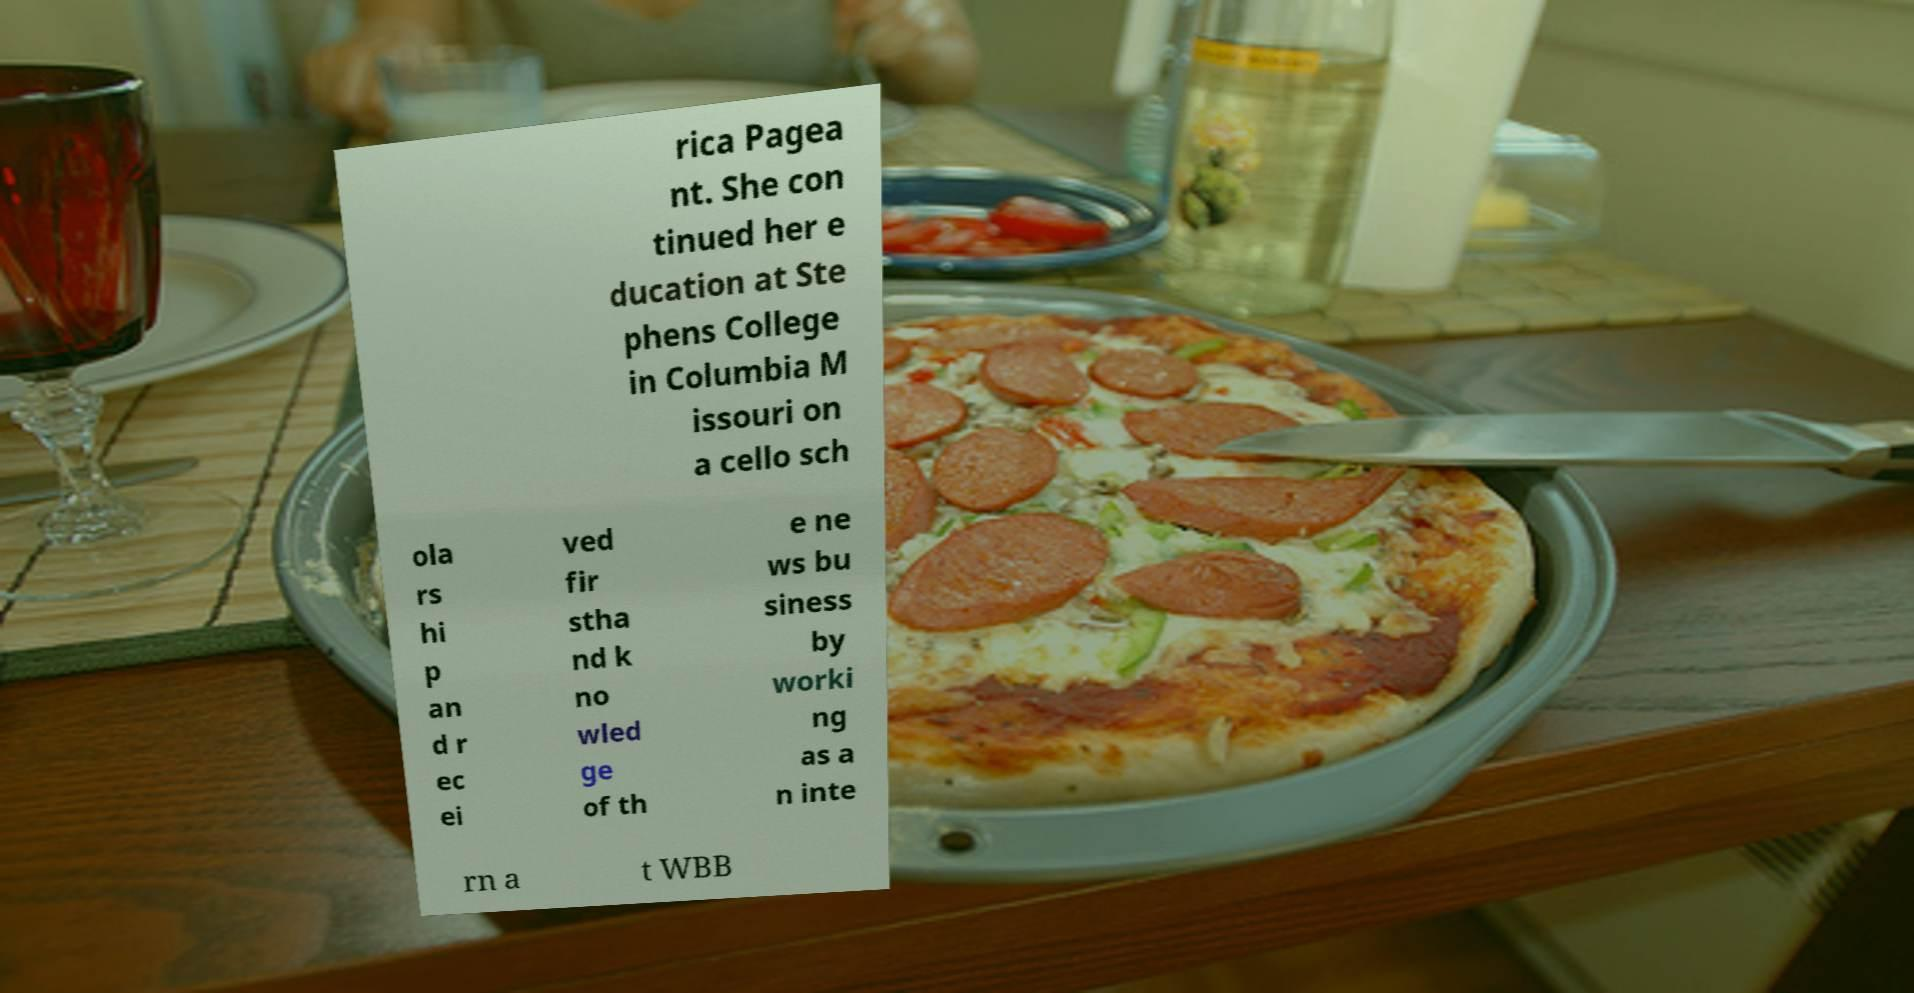Please identify and transcribe the text found in this image. rica Pagea nt. She con tinued her e ducation at Ste phens College in Columbia M issouri on a cello sch ola rs hi p an d r ec ei ved fir stha nd k no wled ge of th e ne ws bu siness by worki ng as a n inte rn a t WBB 